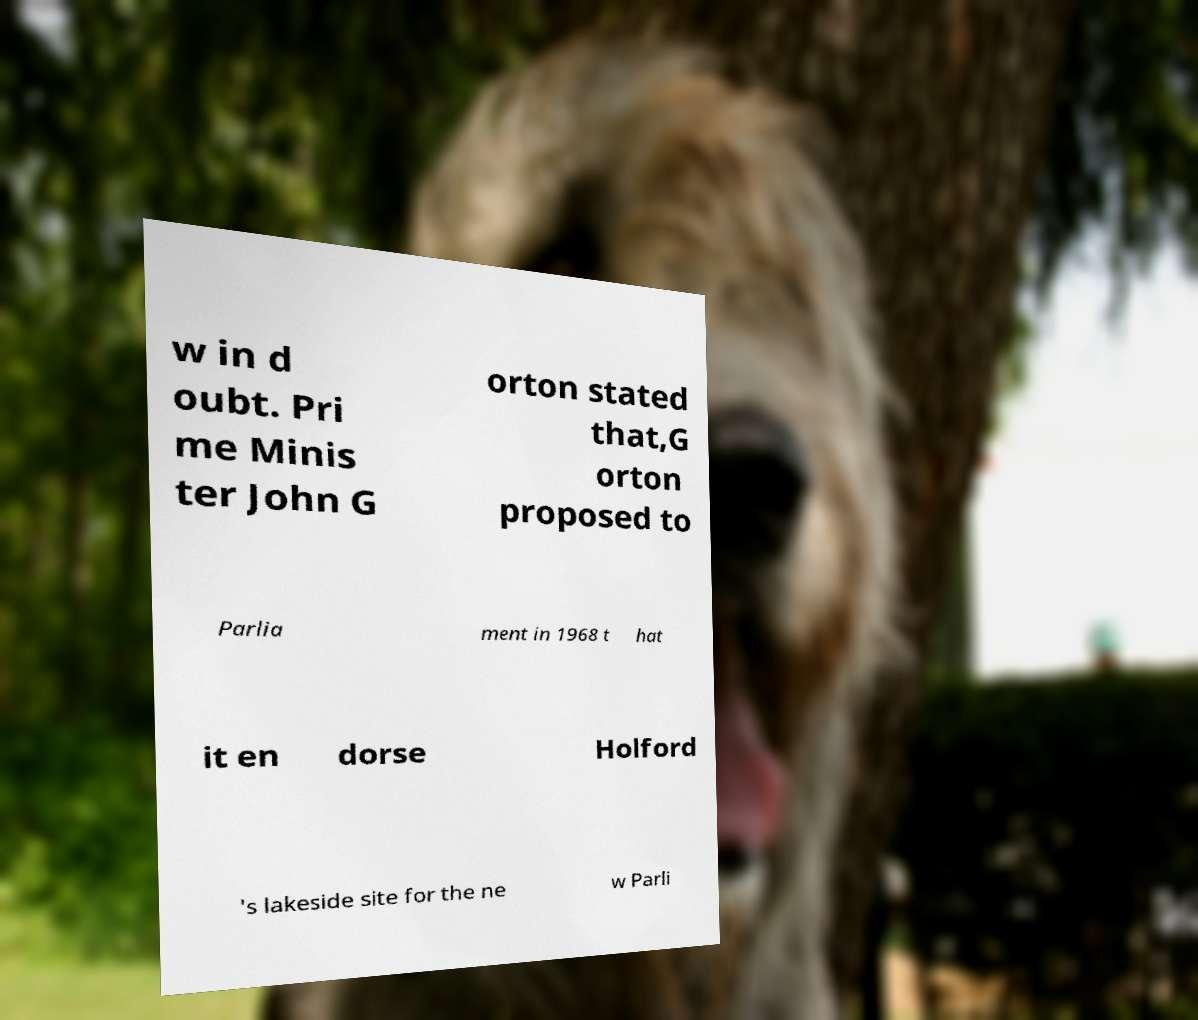Can you read and provide the text displayed in the image?This photo seems to have some interesting text. Can you extract and type it out for me? w in d oubt. Pri me Minis ter John G orton stated that,G orton proposed to Parlia ment in 1968 t hat it en dorse Holford 's lakeside site for the ne w Parli 